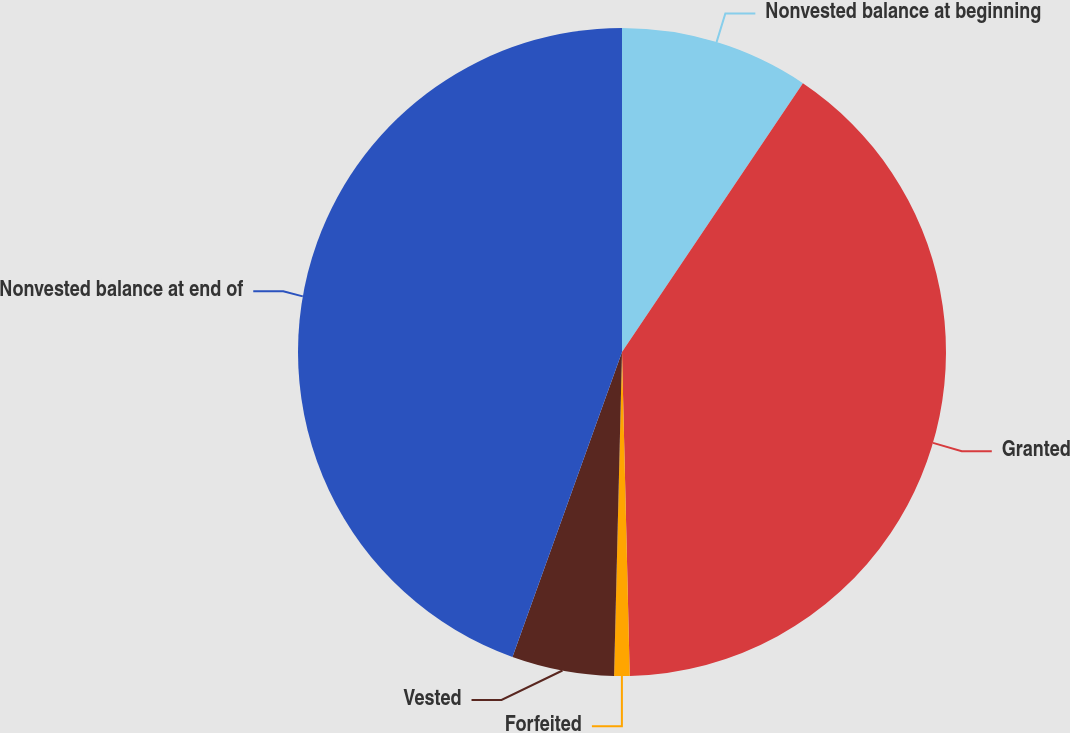Convert chart to OTSL. <chart><loc_0><loc_0><loc_500><loc_500><pie_chart><fcel>Nonvested balance at beginning<fcel>Granted<fcel>Forfeited<fcel>Vested<fcel>Nonvested balance at end of<nl><fcel>9.43%<fcel>40.19%<fcel>0.77%<fcel>5.1%<fcel>44.51%<nl></chart> 